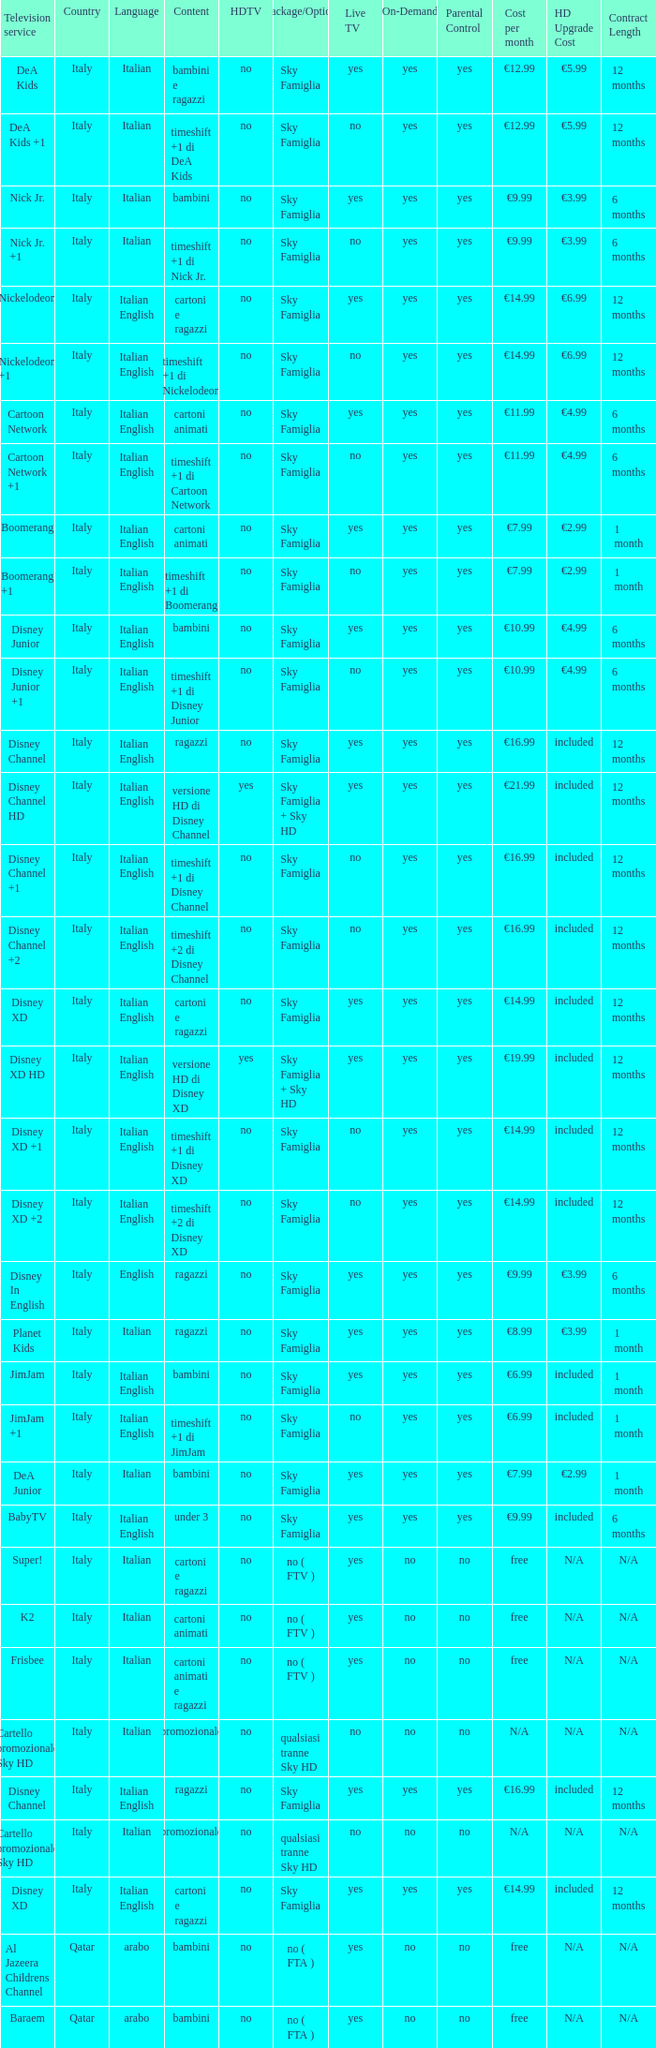What is the HDTV when the Package/Option is sky famiglia, and a Television service of boomerang +1? No. 